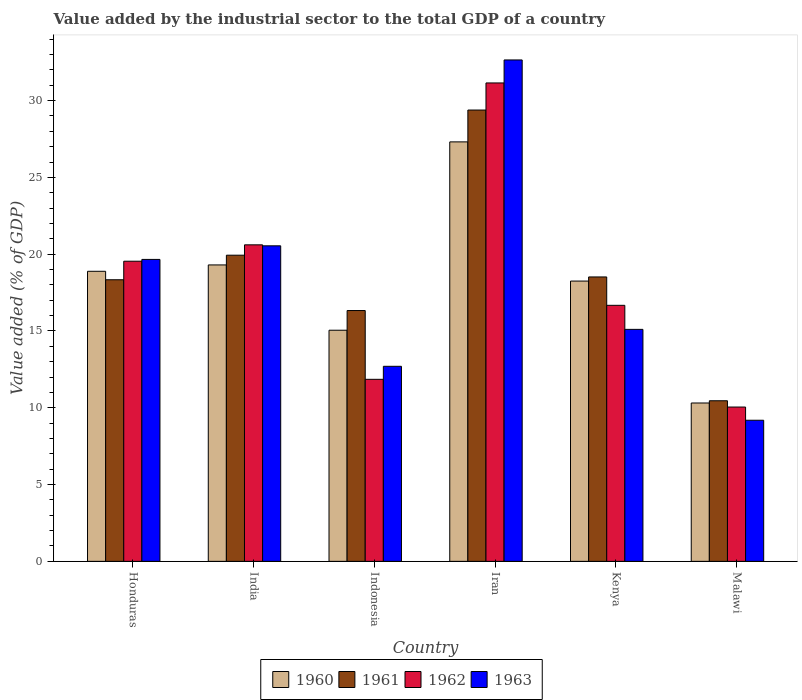How many groups of bars are there?
Keep it short and to the point. 6. Are the number of bars on each tick of the X-axis equal?
Provide a short and direct response. Yes. What is the label of the 2nd group of bars from the left?
Your response must be concise. India. What is the value added by the industrial sector to the total GDP in 1963 in Malawi?
Provide a short and direct response. 9.19. Across all countries, what is the maximum value added by the industrial sector to the total GDP in 1962?
Make the answer very short. 31.15. Across all countries, what is the minimum value added by the industrial sector to the total GDP in 1960?
Offer a terse response. 10.31. In which country was the value added by the industrial sector to the total GDP in 1961 maximum?
Your response must be concise. Iran. In which country was the value added by the industrial sector to the total GDP in 1961 minimum?
Give a very brief answer. Malawi. What is the total value added by the industrial sector to the total GDP in 1961 in the graph?
Your answer should be compact. 112.96. What is the difference between the value added by the industrial sector to the total GDP in 1962 in India and that in Kenya?
Make the answer very short. 3.94. What is the difference between the value added by the industrial sector to the total GDP in 1961 in Honduras and the value added by the industrial sector to the total GDP in 1960 in India?
Offer a terse response. -0.96. What is the average value added by the industrial sector to the total GDP in 1963 per country?
Your answer should be compact. 18.31. What is the difference between the value added by the industrial sector to the total GDP of/in 1962 and value added by the industrial sector to the total GDP of/in 1963 in Malawi?
Your response must be concise. 0.86. In how many countries, is the value added by the industrial sector to the total GDP in 1963 greater than 7 %?
Offer a very short reply. 6. What is the ratio of the value added by the industrial sector to the total GDP in 1960 in Iran to that in Kenya?
Offer a very short reply. 1.5. Is the difference between the value added by the industrial sector to the total GDP in 1962 in Honduras and Iran greater than the difference between the value added by the industrial sector to the total GDP in 1963 in Honduras and Iran?
Your response must be concise. Yes. What is the difference between the highest and the second highest value added by the industrial sector to the total GDP in 1961?
Offer a terse response. -1.42. What is the difference between the highest and the lowest value added by the industrial sector to the total GDP in 1960?
Your response must be concise. 17. In how many countries, is the value added by the industrial sector to the total GDP in 1960 greater than the average value added by the industrial sector to the total GDP in 1960 taken over all countries?
Provide a short and direct response. 4. Is the sum of the value added by the industrial sector to the total GDP in 1960 in India and Indonesia greater than the maximum value added by the industrial sector to the total GDP in 1961 across all countries?
Give a very brief answer. Yes. Is it the case that in every country, the sum of the value added by the industrial sector to the total GDP in 1962 and value added by the industrial sector to the total GDP in 1960 is greater than the sum of value added by the industrial sector to the total GDP in 1961 and value added by the industrial sector to the total GDP in 1963?
Make the answer very short. No. What does the 1st bar from the left in Honduras represents?
Provide a succinct answer. 1960. What does the 4th bar from the right in Kenya represents?
Give a very brief answer. 1960. How many bars are there?
Offer a very short reply. 24. Does the graph contain any zero values?
Keep it short and to the point. No. Does the graph contain grids?
Offer a very short reply. No. Where does the legend appear in the graph?
Make the answer very short. Bottom center. How are the legend labels stacked?
Provide a short and direct response. Horizontal. What is the title of the graph?
Give a very brief answer. Value added by the industrial sector to the total GDP of a country. Does "2013" appear as one of the legend labels in the graph?
Offer a terse response. No. What is the label or title of the Y-axis?
Ensure brevity in your answer.  Value added (% of GDP). What is the Value added (% of GDP) of 1960 in Honduras?
Ensure brevity in your answer.  18.89. What is the Value added (% of GDP) in 1961 in Honduras?
Give a very brief answer. 18.33. What is the Value added (% of GDP) in 1962 in Honduras?
Provide a short and direct response. 19.54. What is the Value added (% of GDP) of 1963 in Honduras?
Your answer should be compact. 19.66. What is the Value added (% of GDP) of 1960 in India?
Your answer should be very brief. 19.3. What is the Value added (% of GDP) in 1961 in India?
Your answer should be very brief. 19.93. What is the Value added (% of GDP) of 1962 in India?
Your answer should be very brief. 20.61. What is the Value added (% of GDP) in 1963 in India?
Provide a succinct answer. 20.54. What is the Value added (% of GDP) of 1960 in Indonesia?
Your answer should be compact. 15.05. What is the Value added (% of GDP) in 1961 in Indonesia?
Your response must be concise. 16.33. What is the Value added (% of GDP) in 1962 in Indonesia?
Offer a terse response. 11.85. What is the Value added (% of GDP) in 1963 in Indonesia?
Make the answer very short. 12.7. What is the Value added (% of GDP) in 1960 in Iran?
Your answer should be very brief. 27.31. What is the Value added (% of GDP) of 1961 in Iran?
Your answer should be very brief. 29.38. What is the Value added (% of GDP) of 1962 in Iran?
Ensure brevity in your answer.  31.15. What is the Value added (% of GDP) of 1963 in Iran?
Keep it short and to the point. 32.65. What is the Value added (% of GDP) in 1960 in Kenya?
Your response must be concise. 18.25. What is the Value added (% of GDP) of 1961 in Kenya?
Your answer should be very brief. 18.52. What is the Value added (% of GDP) in 1962 in Kenya?
Offer a very short reply. 16.67. What is the Value added (% of GDP) in 1963 in Kenya?
Offer a terse response. 15.1. What is the Value added (% of GDP) in 1960 in Malawi?
Your response must be concise. 10.31. What is the Value added (% of GDP) in 1961 in Malawi?
Offer a very short reply. 10.46. What is the Value added (% of GDP) of 1962 in Malawi?
Provide a short and direct response. 10.05. What is the Value added (% of GDP) of 1963 in Malawi?
Your response must be concise. 9.19. Across all countries, what is the maximum Value added (% of GDP) in 1960?
Your answer should be compact. 27.31. Across all countries, what is the maximum Value added (% of GDP) in 1961?
Make the answer very short. 29.38. Across all countries, what is the maximum Value added (% of GDP) in 1962?
Keep it short and to the point. 31.15. Across all countries, what is the maximum Value added (% of GDP) in 1963?
Your response must be concise. 32.65. Across all countries, what is the minimum Value added (% of GDP) in 1960?
Your answer should be compact. 10.31. Across all countries, what is the minimum Value added (% of GDP) of 1961?
Your answer should be very brief. 10.46. Across all countries, what is the minimum Value added (% of GDP) of 1962?
Provide a short and direct response. 10.05. Across all countries, what is the minimum Value added (% of GDP) in 1963?
Provide a succinct answer. 9.19. What is the total Value added (% of GDP) of 1960 in the graph?
Ensure brevity in your answer.  109.11. What is the total Value added (% of GDP) in 1961 in the graph?
Your answer should be very brief. 112.96. What is the total Value added (% of GDP) of 1962 in the graph?
Ensure brevity in your answer.  109.87. What is the total Value added (% of GDP) in 1963 in the graph?
Give a very brief answer. 109.84. What is the difference between the Value added (% of GDP) in 1960 in Honduras and that in India?
Your answer should be compact. -0.41. What is the difference between the Value added (% of GDP) in 1961 in Honduras and that in India?
Ensure brevity in your answer.  -1.6. What is the difference between the Value added (% of GDP) in 1962 in Honduras and that in India?
Keep it short and to the point. -1.07. What is the difference between the Value added (% of GDP) in 1963 in Honduras and that in India?
Keep it short and to the point. -0.88. What is the difference between the Value added (% of GDP) of 1960 in Honduras and that in Indonesia?
Provide a short and direct response. 3.84. What is the difference between the Value added (% of GDP) in 1961 in Honduras and that in Indonesia?
Make the answer very short. 2. What is the difference between the Value added (% of GDP) of 1962 in Honduras and that in Indonesia?
Offer a terse response. 7.69. What is the difference between the Value added (% of GDP) in 1963 in Honduras and that in Indonesia?
Make the answer very short. 6.96. What is the difference between the Value added (% of GDP) of 1960 in Honduras and that in Iran?
Provide a short and direct response. -8.43. What is the difference between the Value added (% of GDP) of 1961 in Honduras and that in Iran?
Ensure brevity in your answer.  -11.05. What is the difference between the Value added (% of GDP) in 1962 in Honduras and that in Iran?
Offer a very short reply. -11.61. What is the difference between the Value added (% of GDP) in 1963 in Honduras and that in Iran?
Give a very brief answer. -12.99. What is the difference between the Value added (% of GDP) of 1960 in Honduras and that in Kenya?
Offer a very short reply. 0.64. What is the difference between the Value added (% of GDP) of 1961 in Honduras and that in Kenya?
Your response must be concise. -0.18. What is the difference between the Value added (% of GDP) of 1962 in Honduras and that in Kenya?
Your answer should be compact. 2.87. What is the difference between the Value added (% of GDP) in 1963 in Honduras and that in Kenya?
Provide a short and direct response. 4.55. What is the difference between the Value added (% of GDP) of 1960 in Honduras and that in Malawi?
Provide a succinct answer. 8.57. What is the difference between the Value added (% of GDP) of 1961 in Honduras and that in Malawi?
Your answer should be compact. 7.88. What is the difference between the Value added (% of GDP) in 1962 in Honduras and that in Malawi?
Ensure brevity in your answer.  9.49. What is the difference between the Value added (% of GDP) in 1963 in Honduras and that in Malawi?
Your answer should be compact. 10.47. What is the difference between the Value added (% of GDP) of 1960 in India and that in Indonesia?
Provide a short and direct response. 4.25. What is the difference between the Value added (% of GDP) in 1961 in India and that in Indonesia?
Provide a succinct answer. 3.6. What is the difference between the Value added (% of GDP) of 1962 in India and that in Indonesia?
Make the answer very short. 8.76. What is the difference between the Value added (% of GDP) in 1963 in India and that in Indonesia?
Offer a very short reply. 7.84. What is the difference between the Value added (% of GDP) of 1960 in India and that in Iran?
Your answer should be compact. -8.01. What is the difference between the Value added (% of GDP) of 1961 in India and that in Iran?
Provide a short and direct response. -9.45. What is the difference between the Value added (% of GDP) of 1962 in India and that in Iran?
Offer a terse response. -10.54. What is the difference between the Value added (% of GDP) of 1963 in India and that in Iran?
Provide a succinct answer. -12.1. What is the difference between the Value added (% of GDP) of 1960 in India and that in Kenya?
Your response must be concise. 1.05. What is the difference between the Value added (% of GDP) of 1961 in India and that in Kenya?
Provide a succinct answer. 1.42. What is the difference between the Value added (% of GDP) in 1962 in India and that in Kenya?
Provide a succinct answer. 3.94. What is the difference between the Value added (% of GDP) in 1963 in India and that in Kenya?
Offer a terse response. 5.44. What is the difference between the Value added (% of GDP) in 1960 in India and that in Malawi?
Make the answer very short. 8.99. What is the difference between the Value added (% of GDP) of 1961 in India and that in Malawi?
Your response must be concise. 9.48. What is the difference between the Value added (% of GDP) in 1962 in India and that in Malawi?
Your response must be concise. 10.56. What is the difference between the Value added (% of GDP) in 1963 in India and that in Malawi?
Keep it short and to the point. 11.36. What is the difference between the Value added (% of GDP) in 1960 in Indonesia and that in Iran?
Ensure brevity in your answer.  -12.26. What is the difference between the Value added (% of GDP) in 1961 in Indonesia and that in Iran?
Offer a very short reply. -13.05. What is the difference between the Value added (% of GDP) of 1962 in Indonesia and that in Iran?
Make the answer very short. -19.3. What is the difference between the Value added (% of GDP) in 1963 in Indonesia and that in Iran?
Keep it short and to the point. -19.95. What is the difference between the Value added (% of GDP) of 1960 in Indonesia and that in Kenya?
Provide a succinct answer. -3.2. What is the difference between the Value added (% of GDP) in 1961 in Indonesia and that in Kenya?
Offer a terse response. -2.19. What is the difference between the Value added (% of GDP) in 1962 in Indonesia and that in Kenya?
Your answer should be compact. -4.82. What is the difference between the Value added (% of GDP) in 1963 in Indonesia and that in Kenya?
Your answer should be compact. -2.4. What is the difference between the Value added (% of GDP) in 1960 in Indonesia and that in Malawi?
Your answer should be compact. 4.74. What is the difference between the Value added (% of GDP) in 1961 in Indonesia and that in Malawi?
Your answer should be compact. 5.87. What is the difference between the Value added (% of GDP) of 1962 in Indonesia and that in Malawi?
Offer a terse response. 1.8. What is the difference between the Value added (% of GDP) of 1963 in Indonesia and that in Malawi?
Offer a very short reply. 3.51. What is the difference between the Value added (% of GDP) in 1960 in Iran and that in Kenya?
Your response must be concise. 9.06. What is the difference between the Value added (% of GDP) in 1961 in Iran and that in Kenya?
Make the answer very short. 10.87. What is the difference between the Value added (% of GDP) in 1962 in Iran and that in Kenya?
Offer a very short reply. 14.48. What is the difference between the Value added (% of GDP) of 1963 in Iran and that in Kenya?
Your answer should be compact. 17.54. What is the difference between the Value added (% of GDP) in 1960 in Iran and that in Malawi?
Give a very brief answer. 17. What is the difference between the Value added (% of GDP) of 1961 in Iran and that in Malawi?
Give a very brief answer. 18.93. What is the difference between the Value added (% of GDP) in 1962 in Iran and that in Malawi?
Offer a terse response. 21.1. What is the difference between the Value added (% of GDP) of 1963 in Iran and that in Malawi?
Offer a terse response. 23.46. What is the difference between the Value added (% of GDP) in 1960 in Kenya and that in Malawi?
Offer a terse response. 7.94. What is the difference between the Value added (% of GDP) in 1961 in Kenya and that in Malawi?
Your response must be concise. 8.06. What is the difference between the Value added (% of GDP) of 1962 in Kenya and that in Malawi?
Your answer should be compact. 6.62. What is the difference between the Value added (% of GDP) of 1963 in Kenya and that in Malawi?
Your answer should be compact. 5.92. What is the difference between the Value added (% of GDP) in 1960 in Honduras and the Value added (% of GDP) in 1961 in India?
Offer a very short reply. -1.05. What is the difference between the Value added (% of GDP) in 1960 in Honduras and the Value added (% of GDP) in 1962 in India?
Give a very brief answer. -1.72. What is the difference between the Value added (% of GDP) of 1960 in Honduras and the Value added (% of GDP) of 1963 in India?
Offer a terse response. -1.66. What is the difference between the Value added (% of GDP) of 1961 in Honduras and the Value added (% of GDP) of 1962 in India?
Your answer should be compact. -2.27. What is the difference between the Value added (% of GDP) in 1961 in Honduras and the Value added (% of GDP) in 1963 in India?
Your response must be concise. -2.21. What is the difference between the Value added (% of GDP) in 1962 in Honduras and the Value added (% of GDP) in 1963 in India?
Offer a very short reply. -1. What is the difference between the Value added (% of GDP) of 1960 in Honduras and the Value added (% of GDP) of 1961 in Indonesia?
Provide a succinct answer. 2.56. What is the difference between the Value added (% of GDP) of 1960 in Honduras and the Value added (% of GDP) of 1962 in Indonesia?
Keep it short and to the point. 7.03. What is the difference between the Value added (% of GDP) in 1960 in Honduras and the Value added (% of GDP) in 1963 in Indonesia?
Your response must be concise. 6.19. What is the difference between the Value added (% of GDP) of 1961 in Honduras and the Value added (% of GDP) of 1962 in Indonesia?
Provide a succinct answer. 6.48. What is the difference between the Value added (% of GDP) in 1961 in Honduras and the Value added (% of GDP) in 1963 in Indonesia?
Keep it short and to the point. 5.64. What is the difference between the Value added (% of GDP) of 1962 in Honduras and the Value added (% of GDP) of 1963 in Indonesia?
Ensure brevity in your answer.  6.84. What is the difference between the Value added (% of GDP) in 1960 in Honduras and the Value added (% of GDP) in 1961 in Iran?
Keep it short and to the point. -10.5. What is the difference between the Value added (% of GDP) of 1960 in Honduras and the Value added (% of GDP) of 1962 in Iran?
Your answer should be very brief. -12.26. What is the difference between the Value added (% of GDP) of 1960 in Honduras and the Value added (% of GDP) of 1963 in Iran?
Offer a terse response. -13.76. What is the difference between the Value added (% of GDP) in 1961 in Honduras and the Value added (% of GDP) in 1962 in Iran?
Make the answer very short. -12.81. What is the difference between the Value added (% of GDP) in 1961 in Honduras and the Value added (% of GDP) in 1963 in Iran?
Keep it short and to the point. -14.31. What is the difference between the Value added (% of GDP) of 1962 in Honduras and the Value added (% of GDP) of 1963 in Iran?
Your response must be concise. -13.1. What is the difference between the Value added (% of GDP) in 1960 in Honduras and the Value added (% of GDP) in 1961 in Kenya?
Ensure brevity in your answer.  0.37. What is the difference between the Value added (% of GDP) in 1960 in Honduras and the Value added (% of GDP) in 1962 in Kenya?
Ensure brevity in your answer.  2.22. What is the difference between the Value added (% of GDP) in 1960 in Honduras and the Value added (% of GDP) in 1963 in Kenya?
Ensure brevity in your answer.  3.78. What is the difference between the Value added (% of GDP) of 1961 in Honduras and the Value added (% of GDP) of 1962 in Kenya?
Give a very brief answer. 1.66. What is the difference between the Value added (% of GDP) of 1961 in Honduras and the Value added (% of GDP) of 1963 in Kenya?
Give a very brief answer. 3.23. What is the difference between the Value added (% of GDP) in 1962 in Honduras and the Value added (% of GDP) in 1963 in Kenya?
Provide a short and direct response. 4.44. What is the difference between the Value added (% of GDP) in 1960 in Honduras and the Value added (% of GDP) in 1961 in Malawi?
Your answer should be very brief. 8.43. What is the difference between the Value added (% of GDP) in 1960 in Honduras and the Value added (% of GDP) in 1962 in Malawi?
Ensure brevity in your answer.  8.84. What is the difference between the Value added (% of GDP) in 1960 in Honduras and the Value added (% of GDP) in 1963 in Malawi?
Provide a succinct answer. 9.7. What is the difference between the Value added (% of GDP) in 1961 in Honduras and the Value added (% of GDP) in 1962 in Malawi?
Provide a succinct answer. 8.29. What is the difference between the Value added (% of GDP) in 1961 in Honduras and the Value added (% of GDP) in 1963 in Malawi?
Your answer should be very brief. 9.15. What is the difference between the Value added (% of GDP) of 1962 in Honduras and the Value added (% of GDP) of 1963 in Malawi?
Make the answer very short. 10.36. What is the difference between the Value added (% of GDP) of 1960 in India and the Value added (% of GDP) of 1961 in Indonesia?
Keep it short and to the point. 2.97. What is the difference between the Value added (% of GDP) in 1960 in India and the Value added (% of GDP) in 1962 in Indonesia?
Your response must be concise. 7.45. What is the difference between the Value added (% of GDP) of 1960 in India and the Value added (% of GDP) of 1963 in Indonesia?
Offer a terse response. 6.6. What is the difference between the Value added (% of GDP) in 1961 in India and the Value added (% of GDP) in 1962 in Indonesia?
Provide a succinct answer. 8.08. What is the difference between the Value added (% of GDP) in 1961 in India and the Value added (% of GDP) in 1963 in Indonesia?
Offer a terse response. 7.23. What is the difference between the Value added (% of GDP) in 1962 in India and the Value added (% of GDP) in 1963 in Indonesia?
Your answer should be very brief. 7.91. What is the difference between the Value added (% of GDP) of 1960 in India and the Value added (% of GDP) of 1961 in Iran?
Offer a terse response. -10.09. What is the difference between the Value added (% of GDP) in 1960 in India and the Value added (% of GDP) in 1962 in Iran?
Ensure brevity in your answer.  -11.85. What is the difference between the Value added (% of GDP) of 1960 in India and the Value added (% of GDP) of 1963 in Iran?
Ensure brevity in your answer.  -13.35. What is the difference between the Value added (% of GDP) in 1961 in India and the Value added (% of GDP) in 1962 in Iran?
Provide a succinct answer. -11.22. What is the difference between the Value added (% of GDP) of 1961 in India and the Value added (% of GDP) of 1963 in Iran?
Provide a short and direct response. -12.71. What is the difference between the Value added (% of GDP) in 1962 in India and the Value added (% of GDP) in 1963 in Iran?
Offer a terse response. -12.04. What is the difference between the Value added (% of GDP) in 1960 in India and the Value added (% of GDP) in 1961 in Kenya?
Give a very brief answer. 0.78. What is the difference between the Value added (% of GDP) in 1960 in India and the Value added (% of GDP) in 1962 in Kenya?
Keep it short and to the point. 2.63. What is the difference between the Value added (% of GDP) of 1960 in India and the Value added (% of GDP) of 1963 in Kenya?
Offer a very short reply. 4.2. What is the difference between the Value added (% of GDP) of 1961 in India and the Value added (% of GDP) of 1962 in Kenya?
Provide a short and direct response. 3.26. What is the difference between the Value added (% of GDP) in 1961 in India and the Value added (% of GDP) in 1963 in Kenya?
Your answer should be compact. 4.83. What is the difference between the Value added (% of GDP) of 1962 in India and the Value added (% of GDP) of 1963 in Kenya?
Provide a short and direct response. 5.5. What is the difference between the Value added (% of GDP) of 1960 in India and the Value added (% of GDP) of 1961 in Malawi?
Offer a very short reply. 8.84. What is the difference between the Value added (% of GDP) in 1960 in India and the Value added (% of GDP) in 1962 in Malawi?
Offer a terse response. 9.25. What is the difference between the Value added (% of GDP) in 1960 in India and the Value added (% of GDP) in 1963 in Malawi?
Offer a very short reply. 10.11. What is the difference between the Value added (% of GDP) of 1961 in India and the Value added (% of GDP) of 1962 in Malawi?
Offer a terse response. 9.89. What is the difference between the Value added (% of GDP) in 1961 in India and the Value added (% of GDP) in 1963 in Malawi?
Make the answer very short. 10.75. What is the difference between the Value added (% of GDP) of 1962 in India and the Value added (% of GDP) of 1963 in Malawi?
Keep it short and to the point. 11.42. What is the difference between the Value added (% of GDP) in 1960 in Indonesia and the Value added (% of GDP) in 1961 in Iran?
Provide a short and direct response. -14.34. What is the difference between the Value added (% of GDP) of 1960 in Indonesia and the Value added (% of GDP) of 1962 in Iran?
Offer a terse response. -16.1. What is the difference between the Value added (% of GDP) in 1960 in Indonesia and the Value added (% of GDP) in 1963 in Iran?
Provide a short and direct response. -17.6. What is the difference between the Value added (% of GDP) of 1961 in Indonesia and the Value added (% of GDP) of 1962 in Iran?
Offer a very short reply. -14.82. What is the difference between the Value added (% of GDP) of 1961 in Indonesia and the Value added (% of GDP) of 1963 in Iran?
Keep it short and to the point. -16.32. What is the difference between the Value added (% of GDP) of 1962 in Indonesia and the Value added (% of GDP) of 1963 in Iran?
Provide a short and direct response. -20.79. What is the difference between the Value added (% of GDP) of 1960 in Indonesia and the Value added (% of GDP) of 1961 in Kenya?
Ensure brevity in your answer.  -3.47. What is the difference between the Value added (% of GDP) of 1960 in Indonesia and the Value added (% of GDP) of 1962 in Kenya?
Your response must be concise. -1.62. What is the difference between the Value added (% of GDP) of 1960 in Indonesia and the Value added (% of GDP) of 1963 in Kenya?
Provide a succinct answer. -0.06. What is the difference between the Value added (% of GDP) in 1961 in Indonesia and the Value added (% of GDP) in 1962 in Kenya?
Your response must be concise. -0.34. What is the difference between the Value added (% of GDP) of 1961 in Indonesia and the Value added (% of GDP) of 1963 in Kenya?
Provide a short and direct response. 1.23. What is the difference between the Value added (% of GDP) of 1962 in Indonesia and the Value added (% of GDP) of 1963 in Kenya?
Your answer should be compact. -3.25. What is the difference between the Value added (% of GDP) in 1960 in Indonesia and the Value added (% of GDP) in 1961 in Malawi?
Offer a terse response. 4.59. What is the difference between the Value added (% of GDP) of 1960 in Indonesia and the Value added (% of GDP) of 1962 in Malawi?
Keep it short and to the point. 5. What is the difference between the Value added (% of GDP) in 1960 in Indonesia and the Value added (% of GDP) in 1963 in Malawi?
Provide a succinct answer. 5.86. What is the difference between the Value added (% of GDP) in 1961 in Indonesia and the Value added (% of GDP) in 1962 in Malawi?
Offer a very short reply. 6.28. What is the difference between the Value added (% of GDP) in 1961 in Indonesia and the Value added (% of GDP) in 1963 in Malawi?
Give a very brief answer. 7.14. What is the difference between the Value added (% of GDP) of 1962 in Indonesia and the Value added (% of GDP) of 1963 in Malawi?
Give a very brief answer. 2.66. What is the difference between the Value added (% of GDP) of 1960 in Iran and the Value added (% of GDP) of 1961 in Kenya?
Your response must be concise. 8.79. What is the difference between the Value added (% of GDP) of 1960 in Iran and the Value added (% of GDP) of 1962 in Kenya?
Ensure brevity in your answer.  10.64. What is the difference between the Value added (% of GDP) of 1960 in Iran and the Value added (% of GDP) of 1963 in Kenya?
Provide a short and direct response. 12.21. What is the difference between the Value added (% of GDP) of 1961 in Iran and the Value added (% of GDP) of 1962 in Kenya?
Your answer should be very brief. 12.71. What is the difference between the Value added (% of GDP) in 1961 in Iran and the Value added (% of GDP) in 1963 in Kenya?
Offer a terse response. 14.28. What is the difference between the Value added (% of GDP) in 1962 in Iran and the Value added (% of GDP) in 1963 in Kenya?
Provide a succinct answer. 16.04. What is the difference between the Value added (% of GDP) of 1960 in Iran and the Value added (% of GDP) of 1961 in Malawi?
Make the answer very short. 16.86. What is the difference between the Value added (% of GDP) of 1960 in Iran and the Value added (% of GDP) of 1962 in Malawi?
Offer a terse response. 17.26. What is the difference between the Value added (% of GDP) in 1960 in Iran and the Value added (% of GDP) in 1963 in Malawi?
Keep it short and to the point. 18.12. What is the difference between the Value added (% of GDP) of 1961 in Iran and the Value added (% of GDP) of 1962 in Malawi?
Make the answer very short. 19.34. What is the difference between the Value added (% of GDP) in 1961 in Iran and the Value added (% of GDP) in 1963 in Malawi?
Provide a short and direct response. 20.2. What is the difference between the Value added (% of GDP) in 1962 in Iran and the Value added (% of GDP) in 1963 in Malawi?
Your answer should be very brief. 21.96. What is the difference between the Value added (% of GDP) of 1960 in Kenya and the Value added (% of GDP) of 1961 in Malawi?
Keep it short and to the point. 7.79. What is the difference between the Value added (% of GDP) in 1960 in Kenya and the Value added (% of GDP) in 1962 in Malawi?
Your response must be concise. 8.2. What is the difference between the Value added (% of GDP) in 1960 in Kenya and the Value added (% of GDP) in 1963 in Malawi?
Provide a short and direct response. 9.06. What is the difference between the Value added (% of GDP) of 1961 in Kenya and the Value added (% of GDP) of 1962 in Malawi?
Offer a very short reply. 8.47. What is the difference between the Value added (% of GDP) in 1961 in Kenya and the Value added (% of GDP) in 1963 in Malawi?
Provide a short and direct response. 9.33. What is the difference between the Value added (% of GDP) of 1962 in Kenya and the Value added (% of GDP) of 1963 in Malawi?
Keep it short and to the point. 7.48. What is the average Value added (% of GDP) in 1960 per country?
Your answer should be very brief. 18.18. What is the average Value added (% of GDP) of 1961 per country?
Keep it short and to the point. 18.83. What is the average Value added (% of GDP) of 1962 per country?
Offer a terse response. 18.31. What is the average Value added (% of GDP) in 1963 per country?
Provide a short and direct response. 18.31. What is the difference between the Value added (% of GDP) in 1960 and Value added (% of GDP) in 1961 in Honduras?
Your answer should be very brief. 0.55. What is the difference between the Value added (% of GDP) of 1960 and Value added (% of GDP) of 1962 in Honduras?
Ensure brevity in your answer.  -0.66. What is the difference between the Value added (% of GDP) of 1960 and Value added (% of GDP) of 1963 in Honduras?
Your response must be concise. -0.77. What is the difference between the Value added (% of GDP) in 1961 and Value added (% of GDP) in 1962 in Honduras?
Your answer should be very brief. -1.21. What is the difference between the Value added (% of GDP) of 1961 and Value added (% of GDP) of 1963 in Honduras?
Your answer should be compact. -1.32. What is the difference between the Value added (% of GDP) of 1962 and Value added (% of GDP) of 1963 in Honduras?
Provide a short and direct response. -0.12. What is the difference between the Value added (% of GDP) of 1960 and Value added (% of GDP) of 1961 in India?
Your answer should be very brief. -0.63. What is the difference between the Value added (% of GDP) in 1960 and Value added (% of GDP) in 1962 in India?
Keep it short and to the point. -1.31. What is the difference between the Value added (% of GDP) of 1960 and Value added (% of GDP) of 1963 in India?
Provide a succinct answer. -1.24. What is the difference between the Value added (% of GDP) of 1961 and Value added (% of GDP) of 1962 in India?
Provide a short and direct response. -0.68. What is the difference between the Value added (% of GDP) of 1961 and Value added (% of GDP) of 1963 in India?
Make the answer very short. -0.61. What is the difference between the Value added (% of GDP) in 1962 and Value added (% of GDP) in 1963 in India?
Offer a very short reply. 0.06. What is the difference between the Value added (% of GDP) in 1960 and Value added (% of GDP) in 1961 in Indonesia?
Offer a very short reply. -1.28. What is the difference between the Value added (% of GDP) of 1960 and Value added (% of GDP) of 1962 in Indonesia?
Your answer should be very brief. 3.2. What is the difference between the Value added (% of GDP) of 1960 and Value added (% of GDP) of 1963 in Indonesia?
Ensure brevity in your answer.  2.35. What is the difference between the Value added (% of GDP) in 1961 and Value added (% of GDP) in 1962 in Indonesia?
Give a very brief answer. 4.48. What is the difference between the Value added (% of GDP) in 1961 and Value added (% of GDP) in 1963 in Indonesia?
Give a very brief answer. 3.63. What is the difference between the Value added (% of GDP) of 1962 and Value added (% of GDP) of 1963 in Indonesia?
Provide a succinct answer. -0.85. What is the difference between the Value added (% of GDP) in 1960 and Value added (% of GDP) in 1961 in Iran?
Keep it short and to the point. -2.07. What is the difference between the Value added (% of GDP) in 1960 and Value added (% of GDP) in 1962 in Iran?
Provide a short and direct response. -3.84. What is the difference between the Value added (% of GDP) in 1960 and Value added (% of GDP) in 1963 in Iran?
Offer a terse response. -5.33. What is the difference between the Value added (% of GDP) in 1961 and Value added (% of GDP) in 1962 in Iran?
Offer a terse response. -1.76. What is the difference between the Value added (% of GDP) in 1961 and Value added (% of GDP) in 1963 in Iran?
Keep it short and to the point. -3.26. What is the difference between the Value added (% of GDP) of 1962 and Value added (% of GDP) of 1963 in Iran?
Your response must be concise. -1.5. What is the difference between the Value added (% of GDP) of 1960 and Value added (% of GDP) of 1961 in Kenya?
Offer a terse response. -0.27. What is the difference between the Value added (% of GDP) of 1960 and Value added (% of GDP) of 1962 in Kenya?
Make the answer very short. 1.58. What is the difference between the Value added (% of GDP) of 1960 and Value added (% of GDP) of 1963 in Kenya?
Your answer should be compact. 3.14. What is the difference between the Value added (% of GDP) of 1961 and Value added (% of GDP) of 1962 in Kenya?
Give a very brief answer. 1.85. What is the difference between the Value added (% of GDP) of 1961 and Value added (% of GDP) of 1963 in Kenya?
Your response must be concise. 3.41. What is the difference between the Value added (% of GDP) in 1962 and Value added (% of GDP) in 1963 in Kenya?
Your answer should be very brief. 1.57. What is the difference between the Value added (% of GDP) in 1960 and Value added (% of GDP) in 1961 in Malawi?
Your response must be concise. -0.15. What is the difference between the Value added (% of GDP) of 1960 and Value added (% of GDP) of 1962 in Malawi?
Provide a short and direct response. 0.26. What is the difference between the Value added (% of GDP) of 1960 and Value added (% of GDP) of 1963 in Malawi?
Provide a succinct answer. 1.12. What is the difference between the Value added (% of GDP) in 1961 and Value added (% of GDP) in 1962 in Malawi?
Provide a short and direct response. 0.41. What is the difference between the Value added (% of GDP) in 1961 and Value added (% of GDP) in 1963 in Malawi?
Offer a terse response. 1.27. What is the difference between the Value added (% of GDP) of 1962 and Value added (% of GDP) of 1963 in Malawi?
Provide a short and direct response. 0.86. What is the ratio of the Value added (% of GDP) of 1960 in Honduras to that in India?
Offer a very short reply. 0.98. What is the ratio of the Value added (% of GDP) of 1961 in Honduras to that in India?
Keep it short and to the point. 0.92. What is the ratio of the Value added (% of GDP) of 1962 in Honduras to that in India?
Keep it short and to the point. 0.95. What is the ratio of the Value added (% of GDP) in 1963 in Honduras to that in India?
Offer a terse response. 0.96. What is the ratio of the Value added (% of GDP) of 1960 in Honduras to that in Indonesia?
Your response must be concise. 1.25. What is the ratio of the Value added (% of GDP) of 1961 in Honduras to that in Indonesia?
Your response must be concise. 1.12. What is the ratio of the Value added (% of GDP) in 1962 in Honduras to that in Indonesia?
Give a very brief answer. 1.65. What is the ratio of the Value added (% of GDP) in 1963 in Honduras to that in Indonesia?
Make the answer very short. 1.55. What is the ratio of the Value added (% of GDP) in 1960 in Honduras to that in Iran?
Ensure brevity in your answer.  0.69. What is the ratio of the Value added (% of GDP) of 1961 in Honduras to that in Iran?
Give a very brief answer. 0.62. What is the ratio of the Value added (% of GDP) of 1962 in Honduras to that in Iran?
Your answer should be very brief. 0.63. What is the ratio of the Value added (% of GDP) of 1963 in Honduras to that in Iran?
Your answer should be very brief. 0.6. What is the ratio of the Value added (% of GDP) of 1960 in Honduras to that in Kenya?
Your response must be concise. 1.03. What is the ratio of the Value added (% of GDP) of 1961 in Honduras to that in Kenya?
Offer a terse response. 0.99. What is the ratio of the Value added (% of GDP) of 1962 in Honduras to that in Kenya?
Offer a terse response. 1.17. What is the ratio of the Value added (% of GDP) of 1963 in Honduras to that in Kenya?
Give a very brief answer. 1.3. What is the ratio of the Value added (% of GDP) in 1960 in Honduras to that in Malawi?
Provide a short and direct response. 1.83. What is the ratio of the Value added (% of GDP) of 1961 in Honduras to that in Malawi?
Offer a terse response. 1.75. What is the ratio of the Value added (% of GDP) of 1962 in Honduras to that in Malawi?
Your answer should be compact. 1.95. What is the ratio of the Value added (% of GDP) in 1963 in Honduras to that in Malawi?
Offer a very short reply. 2.14. What is the ratio of the Value added (% of GDP) of 1960 in India to that in Indonesia?
Make the answer very short. 1.28. What is the ratio of the Value added (% of GDP) of 1961 in India to that in Indonesia?
Provide a short and direct response. 1.22. What is the ratio of the Value added (% of GDP) of 1962 in India to that in Indonesia?
Keep it short and to the point. 1.74. What is the ratio of the Value added (% of GDP) in 1963 in India to that in Indonesia?
Your answer should be very brief. 1.62. What is the ratio of the Value added (% of GDP) of 1960 in India to that in Iran?
Offer a very short reply. 0.71. What is the ratio of the Value added (% of GDP) of 1961 in India to that in Iran?
Your answer should be compact. 0.68. What is the ratio of the Value added (% of GDP) of 1962 in India to that in Iran?
Give a very brief answer. 0.66. What is the ratio of the Value added (% of GDP) in 1963 in India to that in Iran?
Give a very brief answer. 0.63. What is the ratio of the Value added (% of GDP) of 1960 in India to that in Kenya?
Provide a short and direct response. 1.06. What is the ratio of the Value added (% of GDP) of 1961 in India to that in Kenya?
Provide a short and direct response. 1.08. What is the ratio of the Value added (% of GDP) of 1962 in India to that in Kenya?
Provide a succinct answer. 1.24. What is the ratio of the Value added (% of GDP) of 1963 in India to that in Kenya?
Make the answer very short. 1.36. What is the ratio of the Value added (% of GDP) of 1960 in India to that in Malawi?
Your answer should be compact. 1.87. What is the ratio of the Value added (% of GDP) of 1961 in India to that in Malawi?
Ensure brevity in your answer.  1.91. What is the ratio of the Value added (% of GDP) of 1962 in India to that in Malawi?
Offer a very short reply. 2.05. What is the ratio of the Value added (% of GDP) in 1963 in India to that in Malawi?
Keep it short and to the point. 2.24. What is the ratio of the Value added (% of GDP) of 1960 in Indonesia to that in Iran?
Keep it short and to the point. 0.55. What is the ratio of the Value added (% of GDP) of 1961 in Indonesia to that in Iran?
Your answer should be very brief. 0.56. What is the ratio of the Value added (% of GDP) in 1962 in Indonesia to that in Iran?
Give a very brief answer. 0.38. What is the ratio of the Value added (% of GDP) in 1963 in Indonesia to that in Iran?
Your answer should be very brief. 0.39. What is the ratio of the Value added (% of GDP) of 1960 in Indonesia to that in Kenya?
Keep it short and to the point. 0.82. What is the ratio of the Value added (% of GDP) of 1961 in Indonesia to that in Kenya?
Your answer should be compact. 0.88. What is the ratio of the Value added (% of GDP) of 1962 in Indonesia to that in Kenya?
Offer a very short reply. 0.71. What is the ratio of the Value added (% of GDP) in 1963 in Indonesia to that in Kenya?
Keep it short and to the point. 0.84. What is the ratio of the Value added (% of GDP) of 1960 in Indonesia to that in Malawi?
Keep it short and to the point. 1.46. What is the ratio of the Value added (% of GDP) of 1961 in Indonesia to that in Malawi?
Provide a succinct answer. 1.56. What is the ratio of the Value added (% of GDP) in 1962 in Indonesia to that in Malawi?
Your answer should be very brief. 1.18. What is the ratio of the Value added (% of GDP) in 1963 in Indonesia to that in Malawi?
Your response must be concise. 1.38. What is the ratio of the Value added (% of GDP) of 1960 in Iran to that in Kenya?
Your answer should be compact. 1.5. What is the ratio of the Value added (% of GDP) of 1961 in Iran to that in Kenya?
Keep it short and to the point. 1.59. What is the ratio of the Value added (% of GDP) of 1962 in Iran to that in Kenya?
Make the answer very short. 1.87. What is the ratio of the Value added (% of GDP) of 1963 in Iran to that in Kenya?
Offer a very short reply. 2.16. What is the ratio of the Value added (% of GDP) in 1960 in Iran to that in Malawi?
Your answer should be compact. 2.65. What is the ratio of the Value added (% of GDP) in 1961 in Iran to that in Malawi?
Offer a terse response. 2.81. What is the ratio of the Value added (% of GDP) of 1962 in Iran to that in Malawi?
Offer a very short reply. 3.1. What is the ratio of the Value added (% of GDP) in 1963 in Iran to that in Malawi?
Keep it short and to the point. 3.55. What is the ratio of the Value added (% of GDP) of 1960 in Kenya to that in Malawi?
Give a very brief answer. 1.77. What is the ratio of the Value added (% of GDP) in 1961 in Kenya to that in Malawi?
Your response must be concise. 1.77. What is the ratio of the Value added (% of GDP) in 1962 in Kenya to that in Malawi?
Provide a succinct answer. 1.66. What is the ratio of the Value added (% of GDP) in 1963 in Kenya to that in Malawi?
Your response must be concise. 1.64. What is the difference between the highest and the second highest Value added (% of GDP) of 1960?
Provide a short and direct response. 8.01. What is the difference between the highest and the second highest Value added (% of GDP) in 1961?
Provide a short and direct response. 9.45. What is the difference between the highest and the second highest Value added (% of GDP) in 1962?
Offer a very short reply. 10.54. What is the difference between the highest and the second highest Value added (% of GDP) of 1963?
Your response must be concise. 12.1. What is the difference between the highest and the lowest Value added (% of GDP) in 1960?
Give a very brief answer. 17. What is the difference between the highest and the lowest Value added (% of GDP) of 1961?
Your response must be concise. 18.93. What is the difference between the highest and the lowest Value added (% of GDP) in 1962?
Offer a very short reply. 21.1. What is the difference between the highest and the lowest Value added (% of GDP) in 1963?
Give a very brief answer. 23.46. 